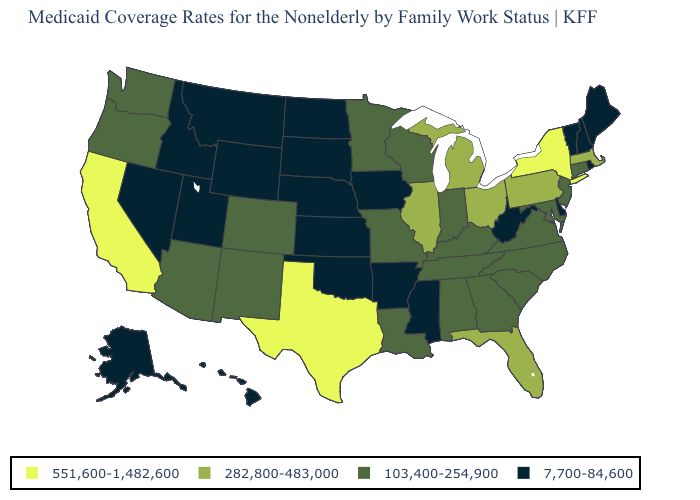Name the states that have a value in the range 551,600-1,482,600?
Be succinct. California, New York, Texas. How many symbols are there in the legend?
Quick response, please. 4. What is the value of Connecticut?
Answer briefly. 103,400-254,900. What is the value of Tennessee?
Concise answer only. 103,400-254,900. What is the highest value in the MidWest ?
Quick response, please. 282,800-483,000. Among the states that border Georgia , does Florida have the highest value?
Keep it brief. Yes. Among the states that border Indiana , does Michigan have the highest value?
Keep it brief. Yes. Does the map have missing data?
Write a very short answer. No. What is the value of Kansas?
Give a very brief answer. 7,700-84,600. What is the lowest value in the USA?
Keep it brief. 7,700-84,600. Does Virginia have the lowest value in the South?
Keep it brief. No. What is the highest value in the USA?
Answer briefly. 551,600-1,482,600. Does Connecticut have the highest value in the Northeast?
Give a very brief answer. No. Does Alaska have a lower value than Mississippi?
Write a very short answer. No. Name the states that have a value in the range 551,600-1,482,600?
Answer briefly. California, New York, Texas. 